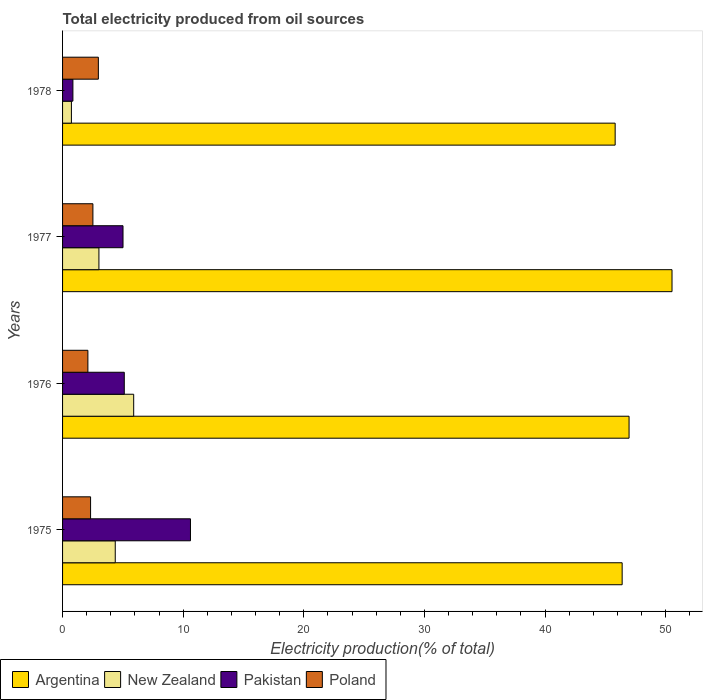How many groups of bars are there?
Your response must be concise. 4. Are the number of bars per tick equal to the number of legend labels?
Give a very brief answer. Yes. What is the label of the 2nd group of bars from the top?
Provide a short and direct response. 1977. What is the total electricity produced in Pakistan in 1975?
Your answer should be compact. 10.6. Across all years, what is the maximum total electricity produced in Argentina?
Ensure brevity in your answer.  50.52. Across all years, what is the minimum total electricity produced in Pakistan?
Provide a short and direct response. 0.86. In which year was the total electricity produced in Argentina maximum?
Make the answer very short. 1977. In which year was the total electricity produced in Pakistan minimum?
Offer a very short reply. 1978. What is the total total electricity produced in Argentina in the graph?
Your answer should be compact. 189.68. What is the difference between the total electricity produced in Argentina in 1976 and that in 1978?
Make the answer very short. 1.15. What is the difference between the total electricity produced in Poland in 1977 and the total electricity produced in Pakistan in 1975?
Make the answer very short. -8.09. What is the average total electricity produced in Pakistan per year?
Keep it short and to the point. 5.4. In the year 1975, what is the difference between the total electricity produced in Poland and total electricity produced in New Zealand?
Ensure brevity in your answer.  -2.05. What is the ratio of the total electricity produced in Poland in 1977 to that in 1978?
Provide a short and direct response. 0.85. Is the difference between the total electricity produced in Poland in 1975 and 1977 greater than the difference between the total electricity produced in New Zealand in 1975 and 1977?
Your answer should be very brief. No. What is the difference between the highest and the second highest total electricity produced in Poland?
Offer a terse response. 0.45. What is the difference between the highest and the lowest total electricity produced in Pakistan?
Provide a succinct answer. 9.75. What does the 1st bar from the top in 1975 represents?
Your answer should be very brief. Poland. How many bars are there?
Offer a very short reply. 16. How many years are there in the graph?
Provide a short and direct response. 4. What is the difference between two consecutive major ticks on the X-axis?
Ensure brevity in your answer.  10. Where does the legend appear in the graph?
Offer a terse response. Bottom left. How many legend labels are there?
Ensure brevity in your answer.  4. What is the title of the graph?
Your response must be concise. Total electricity produced from oil sources. Does "Micronesia" appear as one of the legend labels in the graph?
Offer a terse response. No. What is the label or title of the Y-axis?
Keep it short and to the point. Years. What is the Electricity production(% of total) in Argentina in 1975?
Give a very brief answer. 46.39. What is the Electricity production(% of total) in New Zealand in 1975?
Your answer should be very brief. 4.37. What is the Electricity production(% of total) of Pakistan in 1975?
Keep it short and to the point. 10.6. What is the Electricity production(% of total) of Poland in 1975?
Make the answer very short. 2.32. What is the Electricity production(% of total) of Argentina in 1976?
Give a very brief answer. 46.96. What is the Electricity production(% of total) of New Zealand in 1976?
Offer a terse response. 5.9. What is the Electricity production(% of total) of Pakistan in 1976?
Offer a terse response. 5.12. What is the Electricity production(% of total) in Poland in 1976?
Provide a succinct answer. 2.1. What is the Electricity production(% of total) in Argentina in 1977?
Provide a succinct answer. 50.52. What is the Electricity production(% of total) in New Zealand in 1977?
Give a very brief answer. 3.01. What is the Electricity production(% of total) of Pakistan in 1977?
Provide a succinct answer. 5.01. What is the Electricity production(% of total) in Poland in 1977?
Ensure brevity in your answer.  2.51. What is the Electricity production(% of total) of Argentina in 1978?
Give a very brief answer. 45.81. What is the Electricity production(% of total) in New Zealand in 1978?
Provide a short and direct response. 0.73. What is the Electricity production(% of total) of Pakistan in 1978?
Make the answer very short. 0.86. What is the Electricity production(% of total) in Poland in 1978?
Ensure brevity in your answer.  2.97. Across all years, what is the maximum Electricity production(% of total) in Argentina?
Keep it short and to the point. 50.52. Across all years, what is the maximum Electricity production(% of total) of New Zealand?
Your answer should be very brief. 5.9. Across all years, what is the maximum Electricity production(% of total) of Pakistan?
Keep it short and to the point. 10.6. Across all years, what is the maximum Electricity production(% of total) of Poland?
Keep it short and to the point. 2.97. Across all years, what is the minimum Electricity production(% of total) in Argentina?
Ensure brevity in your answer.  45.81. Across all years, what is the minimum Electricity production(% of total) of New Zealand?
Ensure brevity in your answer.  0.73. Across all years, what is the minimum Electricity production(% of total) of Pakistan?
Keep it short and to the point. 0.86. Across all years, what is the minimum Electricity production(% of total) of Poland?
Offer a very short reply. 2.1. What is the total Electricity production(% of total) of Argentina in the graph?
Offer a very short reply. 189.68. What is the total Electricity production(% of total) in New Zealand in the graph?
Offer a terse response. 14.01. What is the total Electricity production(% of total) of Pakistan in the graph?
Make the answer very short. 21.59. What is the total Electricity production(% of total) in Poland in the graph?
Your response must be concise. 9.9. What is the difference between the Electricity production(% of total) in Argentina in 1975 and that in 1976?
Offer a terse response. -0.57. What is the difference between the Electricity production(% of total) of New Zealand in 1975 and that in 1976?
Your response must be concise. -1.53. What is the difference between the Electricity production(% of total) of Pakistan in 1975 and that in 1976?
Make the answer very short. 5.49. What is the difference between the Electricity production(% of total) of Poland in 1975 and that in 1976?
Ensure brevity in your answer.  0.22. What is the difference between the Electricity production(% of total) of Argentina in 1975 and that in 1977?
Offer a terse response. -4.13. What is the difference between the Electricity production(% of total) of New Zealand in 1975 and that in 1977?
Make the answer very short. 1.35. What is the difference between the Electricity production(% of total) in Pakistan in 1975 and that in 1977?
Provide a succinct answer. 5.59. What is the difference between the Electricity production(% of total) in Poland in 1975 and that in 1977?
Make the answer very short. -0.19. What is the difference between the Electricity production(% of total) of Argentina in 1975 and that in 1978?
Give a very brief answer. 0.58. What is the difference between the Electricity production(% of total) of New Zealand in 1975 and that in 1978?
Offer a very short reply. 3.63. What is the difference between the Electricity production(% of total) of Pakistan in 1975 and that in 1978?
Provide a succinct answer. 9.75. What is the difference between the Electricity production(% of total) of Poland in 1975 and that in 1978?
Provide a short and direct response. -0.65. What is the difference between the Electricity production(% of total) of Argentina in 1976 and that in 1977?
Provide a succinct answer. -3.56. What is the difference between the Electricity production(% of total) in New Zealand in 1976 and that in 1977?
Ensure brevity in your answer.  2.88. What is the difference between the Electricity production(% of total) in Pakistan in 1976 and that in 1977?
Your answer should be compact. 0.11. What is the difference between the Electricity production(% of total) of Poland in 1976 and that in 1977?
Your answer should be very brief. -0.42. What is the difference between the Electricity production(% of total) in Argentina in 1976 and that in 1978?
Your answer should be compact. 1.15. What is the difference between the Electricity production(% of total) of New Zealand in 1976 and that in 1978?
Keep it short and to the point. 5.16. What is the difference between the Electricity production(% of total) of Pakistan in 1976 and that in 1978?
Your answer should be compact. 4.26. What is the difference between the Electricity production(% of total) in Poland in 1976 and that in 1978?
Provide a succinct answer. -0.87. What is the difference between the Electricity production(% of total) in Argentina in 1977 and that in 1978?
Offer a terse response. 4.71. What is the difference between the Electricity production(% of total) of New Zealand in 1977 and that in 1978?
Keep it short and to the point. 2.28. What is the difference between the Electricity production(% of total) of Pakistan in 1977 and that in 1978?
Your answer should be very brief. 4.15. What is the difference between the Electricity production(% of total) in Poland in 1977 and that in 1978?
Provide a short and direct response. -0.45. What is the difference between the Electricity production(% of total) in Argentina in 1975 and the Electricity production(% of total) in New Zealand in 1976?
Offer a terse response. 40.49. What is the difference between the Electricity production(% of total) in Argentina in 1975 and the Electricity production(% of total) in Pakistan in 1976?
Provide a succinct answer. 41.27. What is the difference between the Electricity production(% of total) in Argentina in 1975 and the Electricity production(% of total) in Poland in 1976?
Your response must be concise. 44.29. What is the difference between the Electricity production(% of total) of New Zealand in 1975 and the Electricity production(% of total) of Pakistan in 1976?
Ensure brevity in your answer.  -0.75. What is the difference between the Electricity production(% of total) of New Zealand in 1975 and the Electricity production(% of total) of Poland in 1976?
Keep it short and to the point. 2.27. What is the difference between the Electricity production(% of total) of Pakistan in 1975 and the Electricity production(% of total) of Poland in 1976?
Your response must be concise. 8.5. What is the difference between the Electricity production(% of total) of Argentina in 1975 and the Electricity production(% of total) of New Zealand in 1977?
Provide a short and direct response. 43.38. What is the difference between the Electricity production(% of total) of Argentina in 1975 and the Electricity production(% of total) of Pakistan in 1977?
Your answer should be compact. 41.38. What is the difference between the Electricity production(% of total) of Argentina in 1975 and the Electricity production(% of total) of Poland in 1977?
Your answer should be very brief. 43.87. What is the difference between the Electricity production(% of total) in New Zealand in 1975 and the Electricity production(% of total) in Pakistan in 1977?
Offer a very short reply. -0.64. What is the difference between the Electricity production(% of total) of New Zealand in 1975 and the Electricity production(% of total) of Poland in 1977?
Your response must be concise. 1.85. What is the difference between the Electricity production(% of total) in Pakistan in 1975 and the Electricity production(% of total) in Poland in 1977?
Give a very brief answer. 8.09. What is the difference between the Electricity production(% of total) in Argentina in 1975 and the Electricity production(% of total) in New Zealand in 1978?
Offer a very short reply. 45.66. What is the difference between the Electricity production(% of total) in Argentina in 1975 and the Electricity production(% of total) in Pakistan in 1978?
Make the answer very short. 45.53. What is the difference between the Electricity production(% of total) of Argentina in 1975 and the Electricity production(% of total) of Poland in 1978?
Provide a succinct answer. 43.42. What is the difference between the Electricity production(% of total) in New Zealand in 1975 and the Electricity production(% of total) in Pakistan in 1978?
Offer a very short reply. 3.51. What is the difference between the Electricity production(% of total) in New Zealand in 1975 and the Electricity production(% of total) in Poland in 1978?
Provide a short and direct response. 1.4. What is the difference between the Electricity production(% of total) in Pakistan in 1975 and the Electricity production(% of total) in Poland in 1978?
Keep it short and to the point. 7.64. What is the difference between the Electricity production(% of total) in Argentina in 1976 and the Electricity production(% of total) in New Zealand in 1977?
Provide a succinct answer. 43.95. What is the difference between the Electricity production(% of total) of Argentina in 1976 and the Electricity production(% of total) of Pakistan in 1977?
Ensure brevity in your answer.  41.95. What is the difference between the Electricity production(% of total) of Argentina in 1976 and the Electricity production(% of total) of Poland in 1977?
Give a very brief answer. 44.45. What is the difference between the Electricity production(% of total) in New Zealand in 1976 and the Electricity production(% of total) in Pakistan in 1977?
Ensure brevity in your answer.  0.89. What is the difference between the Electricity production(% of total) of New Zealand in 1976 and the Electricity production(% of total) of Poland in 1977?
Keep it short and to the point. 3.38. What is the difference between the Electricity production(% of total) of Pakistan in 1976 and the Electricity production(% of total) of Poland in 1977?
Your answer should be very brief. 2.6. What is the difference between the Electricity production(% of total) of Argentina in 1976 and the Electricity production(% of total) of New Zealand in 1978?
Provide a succinct answer. 46.23. What is the difference between the Electricity production(% of total) in Argentina in 1976 and the Electricity production(% of total) in Pakistan in 1978?
Your response must be concise. 46.11. What is the difference between the Electricity production(% of total) of Argentina in 1976 and the Electricity production(% of total) of Poland in 1978?
Keep it short and to the point. 43.99. What is the difference between the Electricity production(% of total) in New Zealand in 1976 and the Electricity production(% of total) in Pakistan in 1978?
Provide a succinct answer. 5.04. What is the difference between the Electricity production(% of total) in New Zealand in 1976 and the Electricity production(% of total) in Poland in 1978?
Offer a very short reply. 2.93. What is the difference between the Electricity production(% of total) of Pakistan in 1976 and the Electricity production(% of total) of Poland in 1978?
Give a very brief answer. 2.15. What is the difference between the Electricity production(% of total) of Argentina in 1977 and the Electricity production(% of total) of New Zealand in 1978?
Keep it short and to the point. 49.79. What is the difference between the Electricity production(% of total) of Argentina in 1977 and the Electricity production(% of total) of Pakistan in 1978?
Provide a succinct answer. 49.67. What is the difference between the Electricity production(% of total) in Argentina in 1977 and the Electricity production(% of total) in Poland in 1978?
Your answer should be compact. 47.56. What is the difference between the Electricity production(% of total) in New Zealand in 1977 and the Electricity production(% of total) in Pakistan in 1978?
Your response must be concise. 2.16. What is the difference between the Electricity production(% of total) of New Zealand in 1977 and the Electricity production(% of total) of Poland in 1978?
Provide a succinct answer. 0.05. What is the difference between the Electricity production(% of total) in Pakistan in 1977 and the Electricity production(% of total) in Poland in 1978?
Give a very brief answer. 2.04. What is the average Electricity production(% of total) of Argentina per year?
Provide a short and direct response. 47.42. What is the average Electricity production(% of total) in New Zealand per year?
Ensure brevity in your answer.  3.5. What is the average Electricity production(% of total) in Pakistan per year?
Provide a succinct answer. 5.4. What is the average Electricity production(% of total) in Poland per year?
Provide a short and direct response. 2.48. In the year 1975, what is the difference between the Electricity production(% of total) in Argentina and Electricity production(% of total) in New Zealand?
Your answer should be very brief. 42.02. In the year 1975, what is the difference between the Electricity production(% of total) in Argentina and Electricity production(% of total) in Pakistan?
Provide a short and direct response. 35.79. In the year 1975, what is the difference between the Electricity production(% of total) in Argentina and Electricity production(% of total) in Poland?
Make the answer very short. 44.07. In the year 1975, what is the difference between the Electricity production(% of total) of New Zealand and Electricity production(% of total) of Pakistan?
Keep it short and to the point. -6.24. In the year 1975, what is the difference between the Electricity production(% of total) of New Zealand and Electricity production(% of total) of Poland?
Offer a very short reply. 2.05. In the year 1975, what is the difference between the Electricity production(% of total) in Pakistan and Electricity production(% of total) in Poland?
Your answer should be compact. 8.28. In the year 1976, what is the difference between the Electricity production(% of total) of Argentina and Electricity production(% of total) of New Zealand?
Offer a very short reply. 41.07. In the year 1976, what is the difference between the Electricity production(% of total) in Argentina and Electricity production(% of total) in Pakistan?
Offer a terse response. 41.85. In the year 1976, what is the difference between the Electricity production(% of total) in Argentina and Electricity production(% of total) in Poland?
Ensure brevity in your answer.  44.86. In the year 1976, what is the difference between the Electricity production(% of total) in New Zealand and Electricity production(% of total) in Pakistan?
Your answer should be very brief. 0.78. In the year 1976, what is the difference between the Electricity production(% of total) in New Zealand and Electricity production(% of total) in Poland?
Provide a succinct answer. 3.8. In the year 1976, what is the difference between the Electricity production(% of total) of Pakistan and Electricity production(% of total) of Poland?
Provide a succinct answer. 3.02. In the year 1977, what is the difference between the Electricity production(% of total) of Argentina and Electricity production(% of total) of New Zealand?
Your response must be concise. 47.51. In the year 1977, what is the difference between the Electricity production(% of total) in Argentina and Electricity production(% of total) in Pakistan?
Your answer should be compact. 45.51. In the year 1977, what is the difference between the Electricity production(% of total) in Argentina and Electricity production(% of total) in Poland?
Offer a very short reply. 48.01. In the year 1977, what is the difference between the Electricity production(% of total) of New Zealand and Electricity production(% of total) of Pakistan?
Your answer should be compact. -2. In the year 1977, what is the difference between the Electricity production(% of total) in New Zealand and Electricity production(% of total) in Poland?
Offer a very short reply. 0.5. In the year 1977, what is the difference between the Electricity production(% of total) in Pakistan and Electricity production(% of total) in Poland?
Your answer should be very brief. 2.5. In the year 1978, what is the difference between the Electricity production(% of total) of Argentina and Electricity production(% of total) of New Zealand?
Keep it short and to the point. 45.08. In the year 1978, what is the difference between the Electricity production(% of total) in Argentina and Electricity production(% of total) in Pakistan?
Provide a short and direct response. 44.95. In the year 1978, what is the difference between the Electricity production(% of total) of Argentina and Electricity production(% of total) of Poland?
Provide a short and direct response. 42.84. In the year 1978, what is the difference between the Electricity production(% of total) of New Zealand and Electricity production(% of total) of Pakistan?
Ensure brevity in your answer.  -0.12. In the year 1978, what is the difference between the Electricity production(% of total) in New Zealand and Electricity production(% of total) in Poland?
Ensure brevity in your answer.  -2.23. In the year 1978, what is the difference between the Electricity production(% of total) of Pakistan and Electricity production(% of total) of Poland?
Make the answer very short. -2.11. What is the ratio of the Electricity production(% of total) of Argentina in 1975 to that in 1976?
Make the answer very short. 0.99. What is the ratio of the Electricity production(% of total) of New Zealand in 1975 to that in 1976?
Give a very brief answer. 0.74. What is the ratio of the Electricity production(% of total) of Pakistan in 1975 to that in 1976?
Ensure brevity in your answer.  2.07. What is the ratio of the Electricity production(% of total) of Poland in 1975 to that in 1976?
Your answer should be compact. 1.11. What is the ratio of the Electricity production(% of total) of Argentina in 1975 to that in 1977?
Provide a succinct answer. 0.92. What is the ratio of the Electricity production(% of total) of New Zealand in 1975 to that in 1977?
Provide a succinct answer. 1.45. What is the ratio of the Electricity production(% of total) in Pakistan in 1975 to that in 1977?
Make the answer very short. 2.12. What is the ratio of the Electricity production(% of total) in Poland in 1975 to that in 1977?
Keep it short and to the point. 0.92. What is the ratio of the Electricity production(% of total) in Argentina in 1975 to that in 1978?
Ensure brevity in your answer.  1.01. What is the ratio of the Electricity production(% of total) of New Zealand in 1975 to that in 1978?
Give a very brief answer. 5.95. What is the ratio of the Electricity production(% of total) in Pakistan in 1975 to that in 1978?
Offer a terse response. 12.38. What is the ratio of the Electricity production(% of total) in Poland in 1975 to that in 1978?
Offer a very short reply. 0.78. What is the ratio of the Electricity production(% of total) in Argentina in 1976 to that in 1977?
Ensure brevity in your answer.  0.93. What is the ratio of the Electricity production(% of total) in New Zealand in 1976 to that in 1977?
Offer a terse response. 1.96. What is the ratio of the Electricity production(% of total) in Pakistan in 1976 to that in 1977?
Provide a succinct answer. 1.02. What is the ratio of the Electricity production(% of total) in Poland in 1976 to that in 1977?
Your answer should be very brief. 0.83. What is the ratio of the Electricity production(% of total) in Argentina in 1976 to that in 1978?
Provide a short and direct response. 1.03. What is the ratio of the Electricity production(% of total) of New Zealand in 1976 to that in 1978?
Ensure brevity in your answer.  8.04. What is the ratio of the Electricity production(% of total) of Pakistan in 1976 to that in 1978?
Make the answer very short. 5.97. What is the ratio of the Electricity production(% of total) in Poland in 1976 to that in 1978?
Provide a succinct answer. 0.71. What is the ratio of the Electricity production(% of total) in Argentina in 1977 to that in 1978?
Provide a succinct answer. 1.1. What is the ratio of the Electricity production(% of total) of New Zealand in 1977 to that in 1978?
Keep it short and to the point. 4.11. What is the ratio of the Electricity production(% of total) of Pakistan in 1977 to that in 1978?
Keep it short and to the point. 5.85. What is the ratio of the Electricity production(% of total) of Poland in 1977 to that in 1978?
Offer a very short reply. 0.85. What is the difference between the highest and the second highest Electricity production(% of total) of Argentina?
Offer a very short reply. 3.56. What is the difference between the highest and the second highest Electricity production(% of total) in New Zealand?
Your answer should be very brief. 1.53. What is the difference between the highest and the second highest Electricity production(% of total) of Pakistan?
Make the answer very short. 5.49. What is the difference between the highest and the second highest Electricity production(% of total) in Poland?
Keep it short and to the point. 0.45. What is the difference between the highest and the lowest Electricity production(% of total) of Argentina?
Make the answer very short. 4.71. What is the difference between the highest and the lowest Electricity production(% of total) in New Zealand?
Make the answer very short. 5.16. What is the difference between the highest and the lowest Electricity production(% of total) in Pakistan?
Your answer should be very brief. 9.75. What is the difference between the highest and the lowest Electricity production(% of total) of Poland?
Your answer should be very brief. 0.87. 